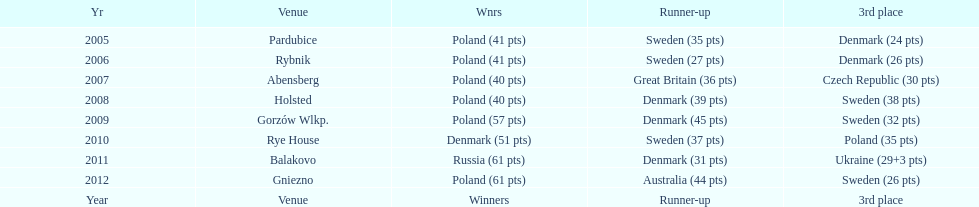From 2005 to 2012, which team accumulated the greatest number of third-place wins in the speedway junior world championship? Sweden. 